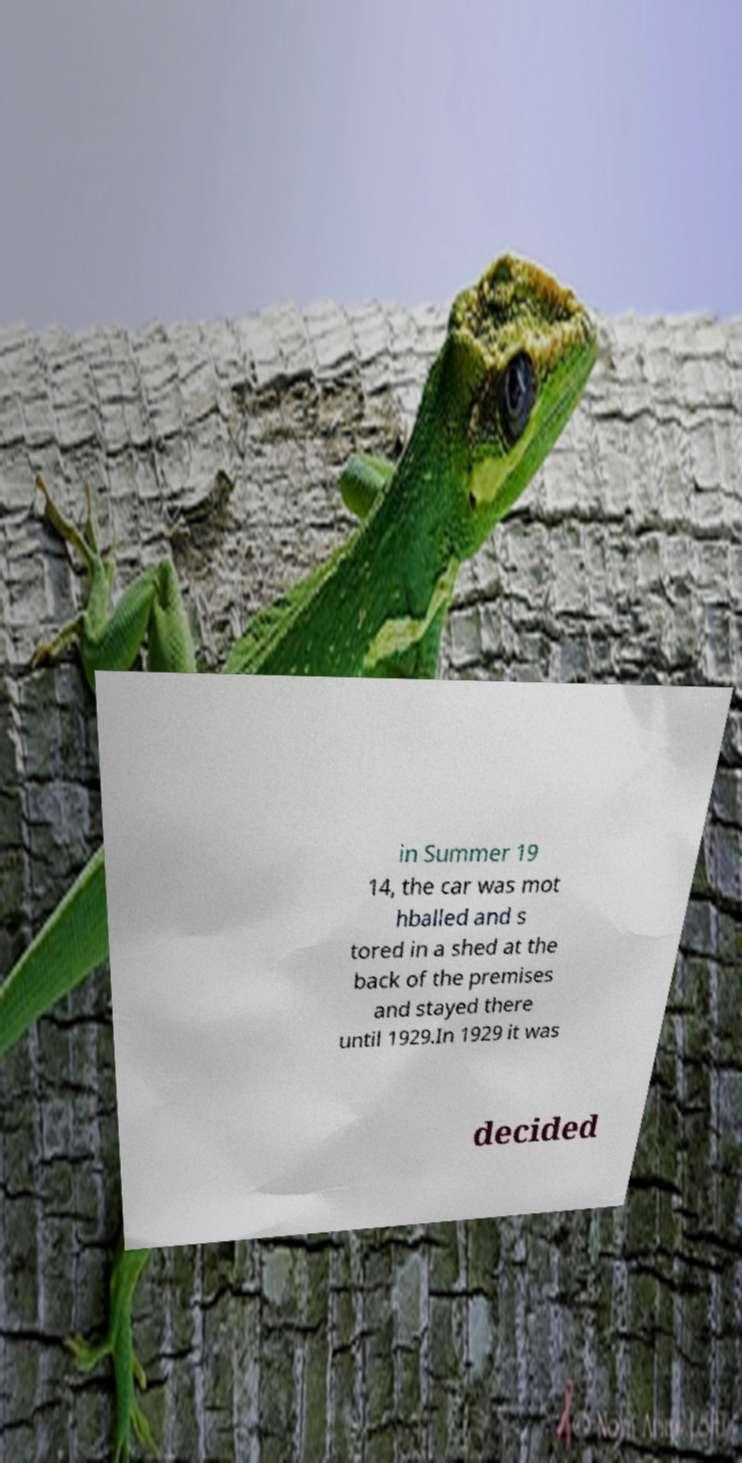Could you assist in decoding the text presented in this image and type it out clearly? in Summer 19 14, the car was mot hballed and s tored in a shed at the back of the premises and stayed there until 1929.In 1929 it was decided 